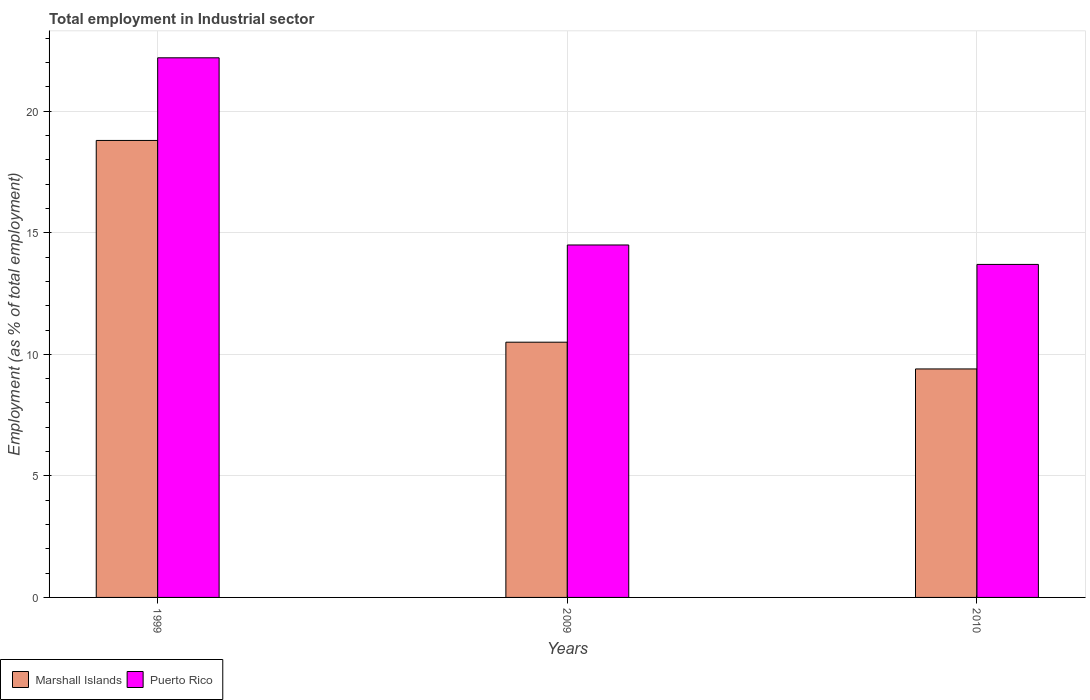Are the number of bars per tick equal to the number of legend labels?
Provide a succinct answer. Yes. How many bars are there on the 3rd tick from the left?
Make the answer very short. 2. What is the label of the 1st group of bars from the left?
Make the answer very short. 1999. What is the employment in industrial sector in Puerto Rico in 1999?
Your answer should be compact. 22.2. Across all years, what is the maximum employment in industrial sector in Marshall Islands?
Give a very brief answer. 18.8. Across all years, what is the minimum employment in industrial sector in Puerto Rico?
Your answer should be compact. 13.7. In which year was the employment in industrial sector in Marshall Islands minimum?
Your response must be concise. 2010. What is the total employment in industrial sector in Marshall Islands in the graph?
Your answer should be very brief. 38.7. What is the difference between the employment in industrial sector in Puerto Rico in 1999 and that in 2009?
Offer a terse response. 7.7. What is the difference between the employment in industrial sector in Puerto Rico in 2009 and the employment in industrial sector in Marshall Islands in 1999?
Keep it short and to the point. -4.3. What is the average employment in industrial sector in Marshall Islands per year?
Ensure brevity in your answer.  12.9. In the year 1999, what is the difference between the employment in industrial sector in Puerto Rico and employment in industrial sector in Marshall Islands?
Offer a terse response. 3.4. What is the ratio of the employment in industrial sector in Puerto Rico in 2009 to that in 2010?
Provide a succinct answer. 1.06. What is the difference between the highest and the second highest employment in industrial sector in Marshall Islands?
Offer a very short reply. 8.3. What is the difference between the highest and the lowest employment in industrial sector in Puerto Rico?
Your answer should be very brief. 8.5. What does the 1st bar from the left in 1999 represents?
Your answer should be very brief. Marshall Islands. What does the 2nd bar from the right in 2010 represents?
Provide a short and direct response. Marshall Islands. How many years are there in the graph?
Offer a terse response. 3. What is the difference between two consecutive major ticks on the Y-axis?
Offer a terse response. 5. Does the graph contain any zero values?
Ensure brevity in your answer.  No. How are the legend labels stacked?
Provide a succinct answer. Horizontal. What is the title of the graph?
Your answer should be very brief. Total employment in Industrial sector. What is the label or title of the Y-axis?
Your answer should be very brief. Employment (as % of total employment). What is the Employment (as % of total employment) in Marshall Islands in 1999?
Offer a very short reply. 18.8. What is the Employment (as % of total employment) of Puerto Rico in 1999?
Keep it short and to the point. 22.2. What is the Employment (as % of total employment) of Puerto Rico in 2009?
Offer a very short reply. 14.5. What is the Employment (as % of total employment) in Marshall Islands in 2010?
Offer a very short reply. 9.4. What is the Employment (as % of total employment) in Puerto Rico in 2010?
Provide a short and direct response. 13.7. Across all years, what is the maximum Employment (as % of total employment) of Marshall Islands?
Give a very brief answer. 18.8. Across all years, what is the maximum Employment (as % of total employment) in Puerto Rico?
Your answer should be very brief. 22.2. Across all years, what is the minimum Employment (as % of total employment) in Marshall Islands?
Give a very brief answer. 9.4. Across all years, what is the minimum Employment (as % of total employment) in Puerto Rico?
Your response must be concise. 13.7. What is the total Employment (as % of total employment) of Marshall Islands in the graph?
Offer a terse response. 38.7. What is the total Employment (as % of total employment) of Puerto Rico in the graph?
Ensure brevity in your answer.  50.4. What is the difference between the Employment (as % of total employment) of Marshall Islands in 1999 and that in 2009?
Give a very brief answer. 8.3. What is the difference between the Employment (as % of total employment) in Puerto Rico in 1999 and that in 2010?
Give a very brief answer. 8.5. What is the difference between the Employment (as % of total employment) of Marshall Islands in 2009 and that in 2010?
Your answer should be compact. 1.1. What is the difference between the Employment (as % of total employment) in Marshall Islands in 1999 and the Employment (as % of total employment) in Puerto Rico in 2009?
Your answer should be compact. 4.3. What is the difference between the Employment (as % of total employment) of Marshall Islands in 2009 and the Employment (as % of total employment) of Puerto Rico in 2010?
Provide a short and direct response. -3.2. In the year 1999, what is the difference between the Employment (as % of total employment) in Marshall Islands and Employment (as % of total employment) in Puerto Rico?
Offer a very short reply. -3.4. In the year 2010, what is the difference between the Employment (as % of total employment) of Marshall Islands and Employment (as % of total employment) of Puerto Rico?
Make the answer very short. -4.3. What is the ratio of the Employment (as % of total employment) in Marshall Islands in 1999 to that in 2009?
Keep it short and to the point. 1.79. What is the ratio of the Employment (as % of total employment) in Puerto Rico in 1999 to that in 2009?
Your answer should be compact. 1.53. What is the ratio of the Employment (as % of total employment) in Marshall Islands in 1999 to that in 2010?
Give a very brief answer. 2. What is the ratio of the Employment (as % of total employment) in Puerto Rico in 1999 to that in 2010?
Your answer should be very brief. 1.62. What is the ratio of the Employment (as % of total employment) of Marshall Islands in 2009 to that in 2010?
Your answer should be very brief. 1.12. What is the ratio of the Employment (as % of total employment) in Puerto Rico in 2009 to that in 2010?
Offer a terse response. 1.06. What is the difference between the highest and the second highest Employment (as % of total employment) of Marshall Islands?
Provide a short and direct response. 8.3. What is the difference between the highest and the second highest Employment (as % of total employment) in Puerto Rico?
Your answer should be very brief. 7.7. What is the difference between the highest and the lowest Employment (as % of total employment) of Marshall Islands?
Make the answer very short. 9.4. What is the difference between the highest and the lowest Employment (as % of total employment) in Puerto Rico?
Offer a very short reply. 8.5. 